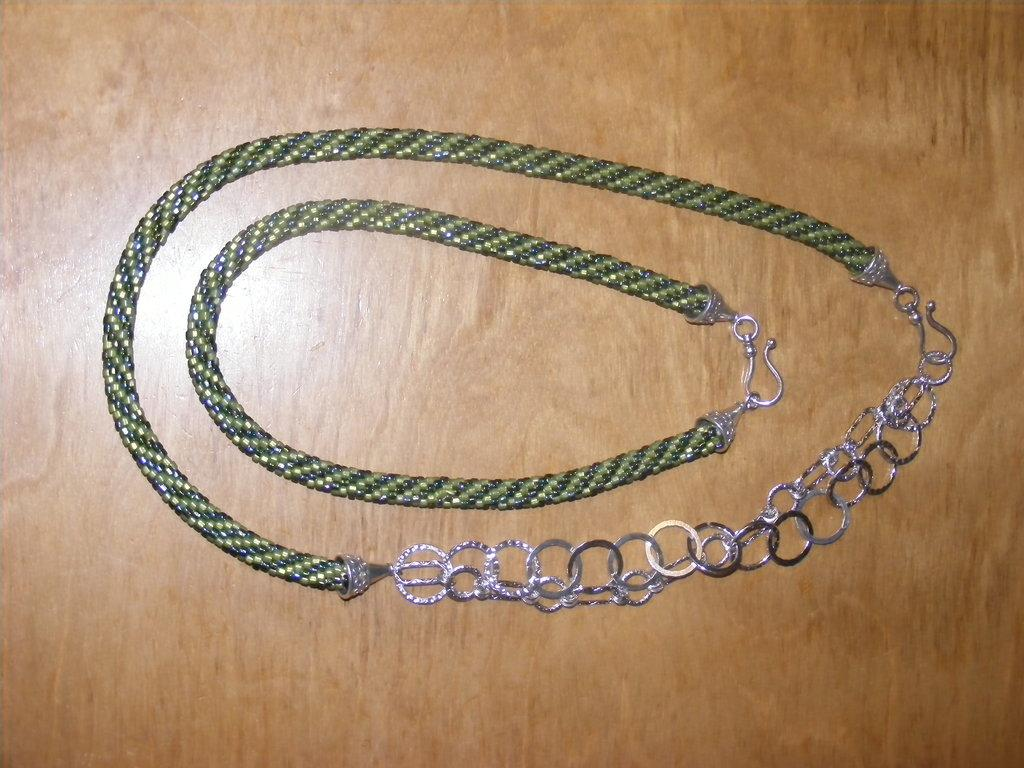What objects are present in the image? There are chains in the image. Where are the chains located? The chains are placed on a table. How many cows can be seen grazing near the boundary in the image? There are no cows or boundaries present in the image; it only features chains placed on a table. 